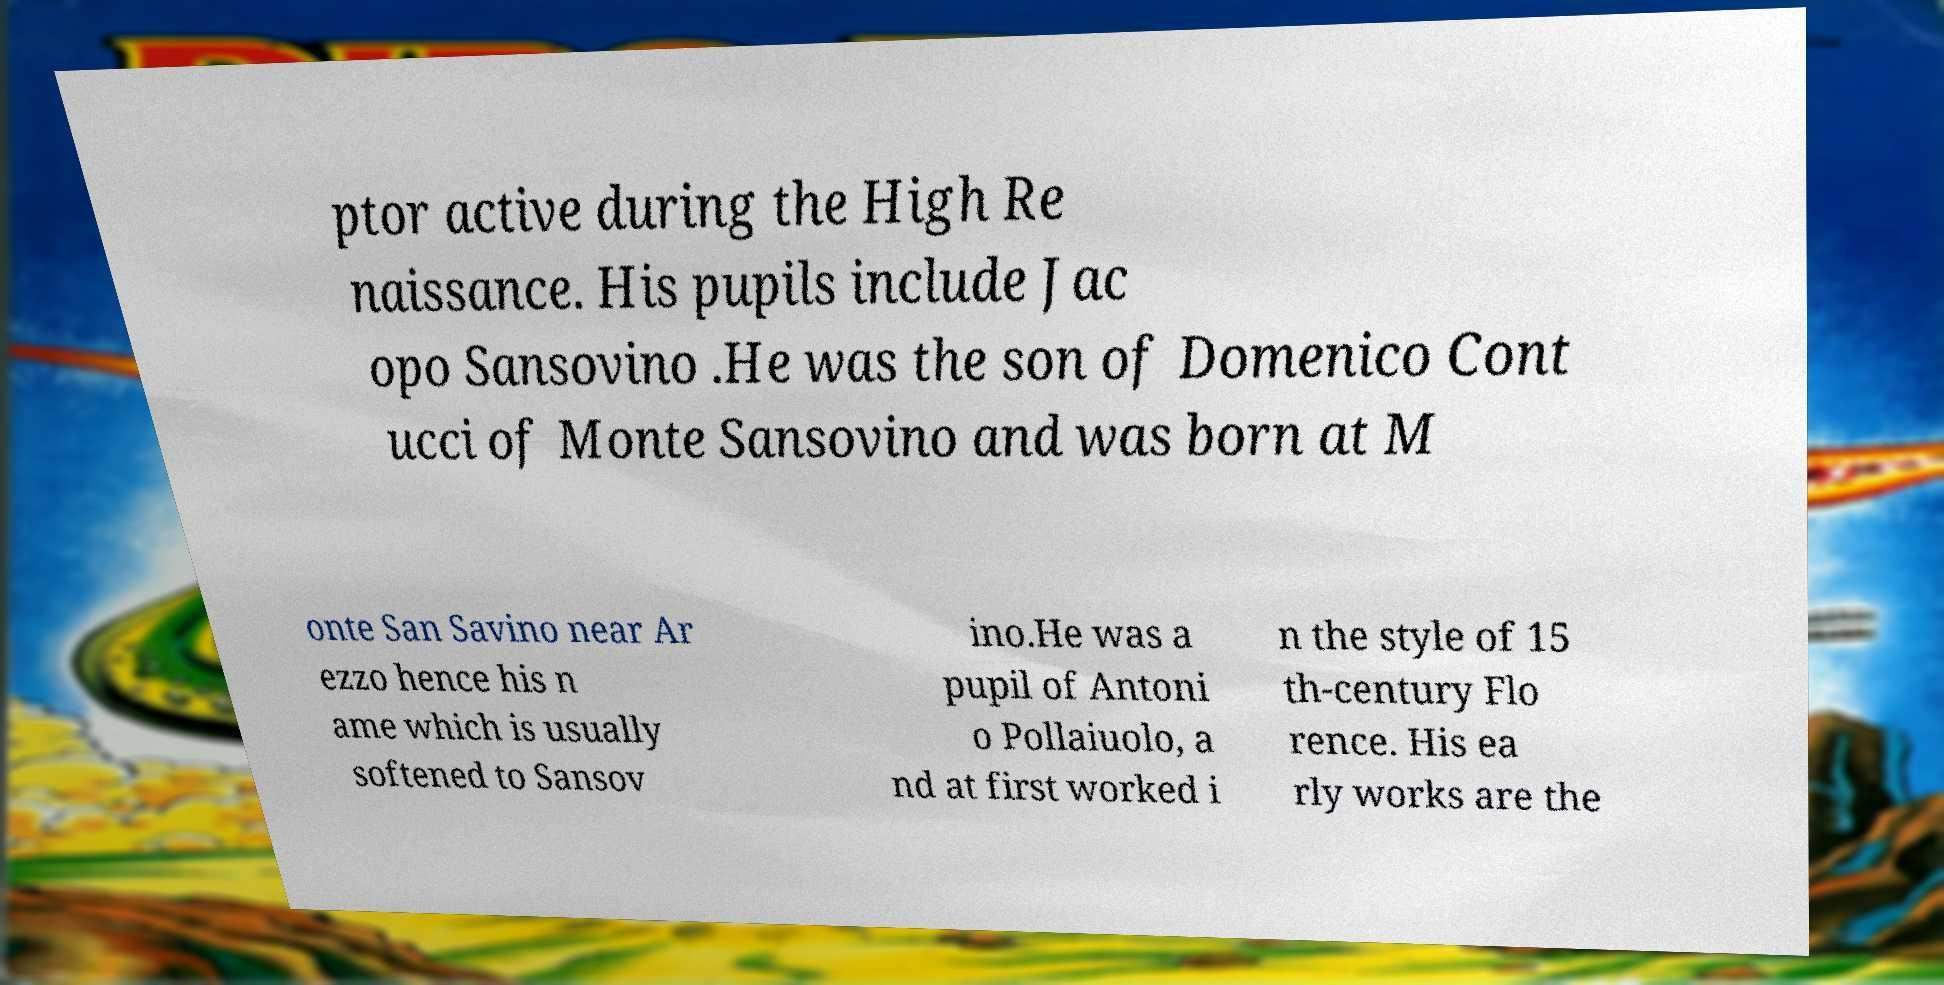I need the written content from this picture converted into text. Can you do that? ptor active during the High Re naissance. His pupils include Jac opo Sansovino .He was the son of Domenico Cont ucci of Monte Sansovino and was born at M onte San Savino near Ar ezzo hence his n ame which is usually softened to Sansov ino.He was a pupil of Antoni o Pollaiuolo, a nd at first worked i n the style of 15 th-century Flo rence. His ea rly works are the 